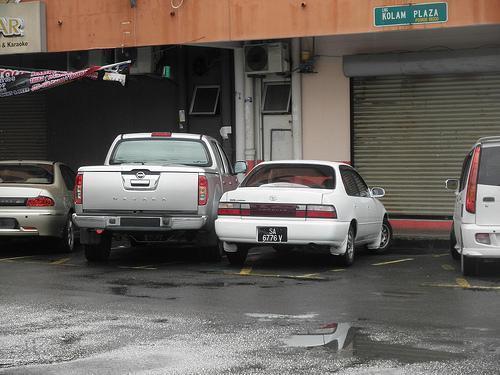How many cars are there?
Give a very brief answer. 4. 